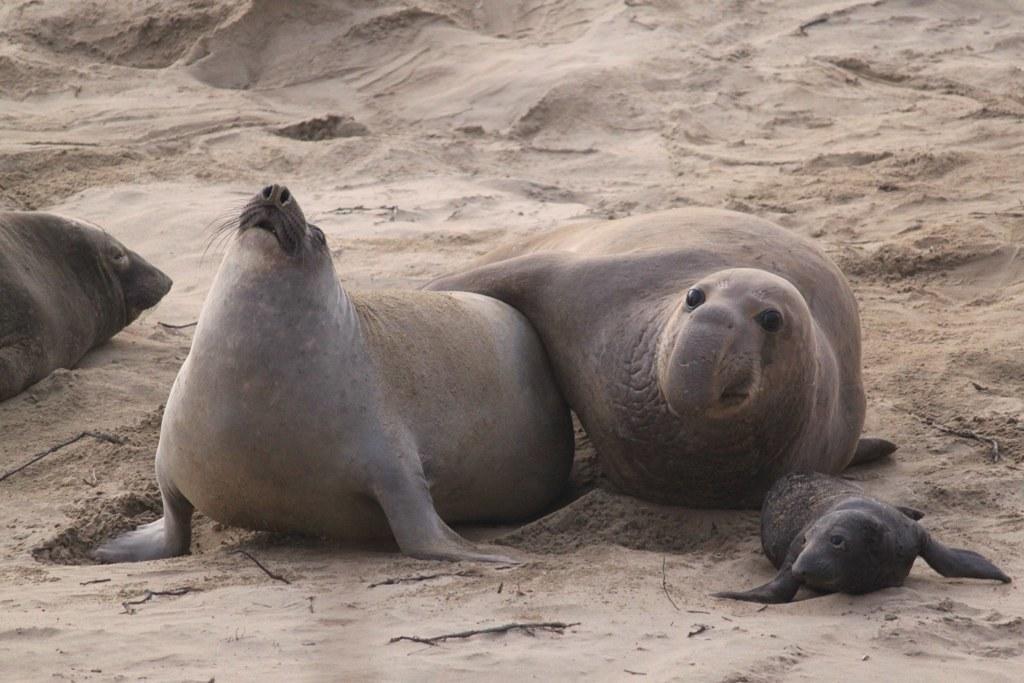Please provide a concise description of this image. This is an outside view. It is looking like a beach. Here I can see the seals on the sand. 